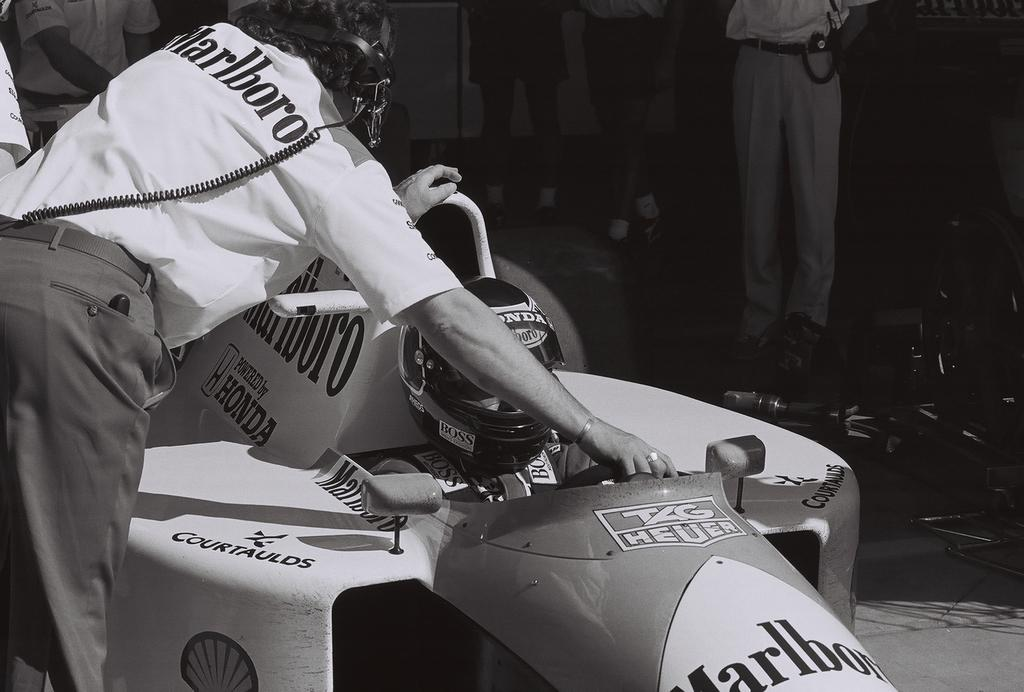What is happening in the image involving the persons and the floor? There are persons standing on the floor in the image. Can you describe the interaction between the persons and the motor vehicle? One of the persons is holding a motor vehicle, and there is a person sitting in the motor vehicle. What type of bean is being used to fuel the motor vehicle in the image? There is no bean present in the image, and the motor vehicle is not being fueled by any type of bean. 